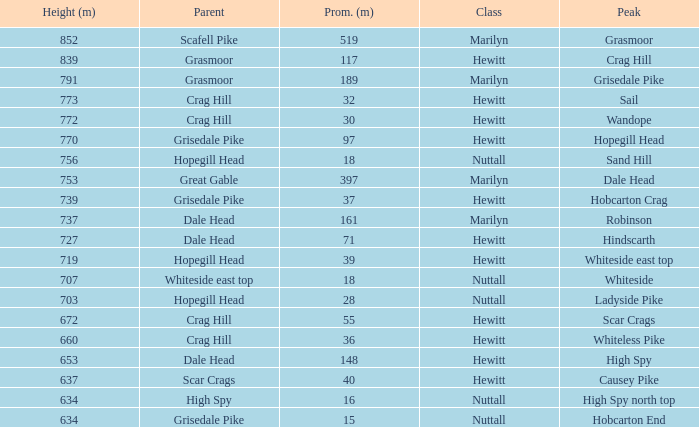What is the lowest height for Parent grasmoor when it has a Prom larger than 117? 791.0. 